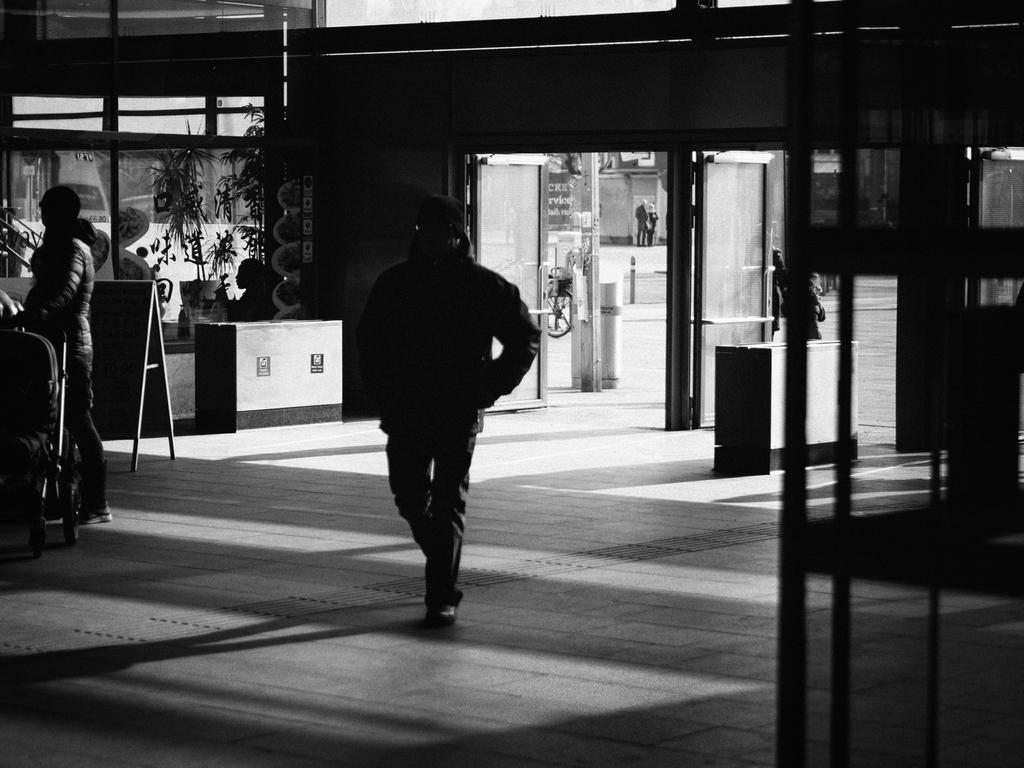What is the primary action of the person in the image? There is a person walking in the image. What is the position of the other person in the image? There is a person standing in the image. What architectural feature can be seen in the image? There is a door visible in the image. What type of meat is being discussed by the committee in the image? There is no committee or meat present in the image; it only features two people and a door. 